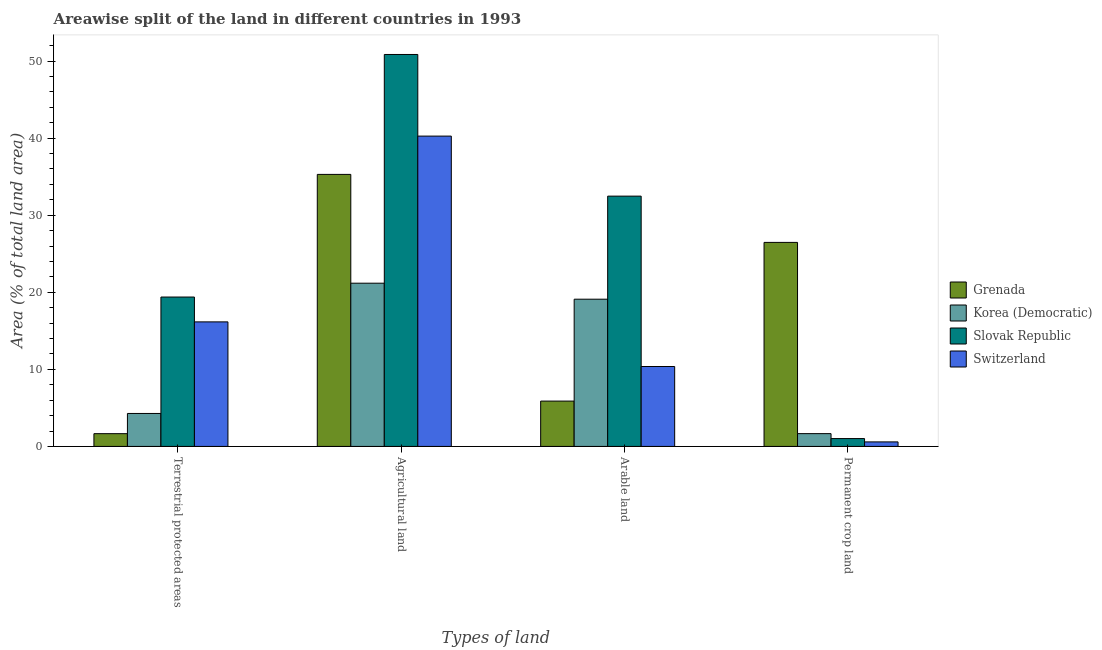How many different coloured bars are there?
Your answer should be very brief. 4. Are the number of bars per tick equal to the number of legend labels?
Provide a succinct answer. Yes. Are the number of bars on each tick of the X-axis equal?
Make the answer very short. Yes. What is the label of the 1st group of bars from the left?
Your response must be concise. Terrestrial protected areas. What is the percentage of area under arable land in Switzerland?
Provide a succinct answer. 10.37. Across all countries, what is the maximum percentage of land under terrestrial protection?
Your response must be concise. 19.38. Across all countries, what is the minimum percentage of area under arable land?
Give a very brief answer. 5.88. In which country was the percentage of area under agricultural land maximum?
Provide a succinct answer. Slovak Republic. In which country was the percentage of area under arable land minimum?
Provide a short and direct response. Grenada. What is the total percentage of area under permanent crop land in the graph?
Keep it short and to the point. 29.74. What is the difference between the percentage of land under terrestrial protection in Grenada and that in Slovak Republic?
Provide a succinct answer. -17.73. What is the difference between the percentage of area under permanent crop land in Slovak Republic and the percentage of area under agricultural land in Grenada?
Your answer should be compact. -34.28. What is the average percentage of area under permanent crop land per country?
Your response must be concise. 7.43. What is the difference between the percentage of area under arable land and percentage of area under permanent crop land in Grenada?
Make the answer very short. -20.59. In how many countries, is the percentage of area under arable land greater than 4 %?
Provide a short and direct response. 4. What is the ratio of the percentage of area under agricultural land in Korea (Democratic) to that in Switzerland?
Give a very brief answer. 0.53. What is the difference between the highest and the second highest percentage of land under terrestrial protection?
Keep it short and to the point. 3.22. What is the difference between the highest and the lowest percentage of land under terrestrial protection?
Offer a very short reply. 17.73. In how many countries, is the percentage of area under agricultural land greater than the average percentage of area under agricultural land taken over all countries?
Your response must be concise. 2. Is the sum of the percentage of area under arable land in Grenada and Switzerland greater than the maximum percentage of area under permanent crop land across all countries?
Offer a terse response. No. Is it the case that in every country, the sum of the percentage of area under arable land and percentage of area under permanent crop land is greater than the sum of percentage of area under agricultural land and percentage of land under terrestrial protection?
Ensure brevity in your answer.  No. What does the 2nd bar from the left in Permanent crop land represents?
Your response must be concise. Korea (Democratic). What does the 3rd bar from the right in Agricultural land represents?
Give a very brief answer. Korea (Democratic). How many bars are there?
Provide a short and direct response. 16. Are all the bars in the graph horizontal?
Provide a short and direct response. No. How many countries are there in the graph?
Make the answer very short. 4. What is the difference between two consecutive major ticks on the Y-axis?
Your answer should be very brief. 10. Does the graph contain any zero values?
Give a very brief answer. No. Does the graph contain grids?
Make the answer very short. No. Where does the legend appear in the graph?
Your answer should be compact. Center right. What is the title of the graph?
Provide a short and direct response. Areawise split of the land in different countries in 1993. Does "Benin" appear as one of the legend labels in the graph?
Keep it short and to the point. No. What is the label or title of the X-axis?
Give a very brief answer. Types of land. What is the label or title of the Y-axis?
Offer a very short reply. Area (% of total land area). What is the Area (% of total land area) in Grenada in Terrestrial protected areas?
Your response must be concise. 1.66. What is the Area (% of total land area) in Korea (Democratic) in Terrestrial protected areas?
Your response must be concise. 4.28. What is the Area (% of total land area) of Slovak Republic in Terrestrial protected areas?
Ensure brevity in your answer.  19.38. What is the Area (% of total land area) of Switzerland in Terrestrial protected areas?
Offer a terse response. 16.16. What is the Area (% of total land area) of Grenada in Agricultural land?
Your answer should be compact. 35.29. What is the Area (% of total land area) in Korea (Democratic) in Agricultural land?
Offer a very short reply. 21.18. What is the Area (% of total land area) in Slovak Republic in Agricultural land?
Your answer should be very brief. 50.85. What is the Area (% of total land area) in Switzerland in Agricultural land?
Your answer should be compact. 40.26. What is the Area (% of total land area) in Grenada in Arable land?
Offer a terse response. 5.88. What is the Area (% of total land area) of Korea (Democratic) in Arable land?
Provide a succinct answer. 19.1. What is the Area (% of total land area) of Slovak Republic in Arable land?
Give a very brief answer. 32.47. What is the Area (% of total land area) of Switzerland in Arable land?
Ensure brevity in your answer.  10.37. What is the Area (% of total land area) in Grenada in Permanent crop land?
Keep it short and to the point. 26.47. What is the Area (% of total land area) in Korea (Democratic) in Permanent crop land?
Offer a very short reply. 1.66. What is the Area (% of total land area) of Slovak Republic in Permanent crop land?
Provide a succinct answer. 1.02. What is the Area (% of total land area) of Switzerland in Permanent crop land?
Your answer should be compact. 0.59. Across all Types of land, what is the maximum Area (% of total land area) of Grenada?
Offer a terse response. 35.29. Across all Types of land, what is the maximum Area (% of total land area) in Korea (Democratic)?
Provide a succinct answer. 21.18. Across all Types of land, what is the maximum Area (% of total land area) of Slovak Republic?
Your answer should be very brief. 50.85. Across all Types of land, what is the maximum Area (% of total land area) of Switzerland?
Make the answer very short. 40.26. Across all Types of land, what is the minimum Area (% of total land area) in Grenada?
Provide a succinct answer. 1.66. Across all Types of land, what is the minimum Area (% of total land area) in Korea (Democratic)?
Your response must be concise. 1.66. Across all Types of land, what is the minimum Area (% of total land area) in Slovak Republic?
Offer a terse response. 1.02. Across all Types of land, what is the minimum Area (% of total land area) in Switzerland?
Give a very brief answer. 0.59. What is the total Area (% of total land area) of Grenada in the graph?
Ensure brevity in your answer.  69.3. What is the total Area (% of total land area) in Korea (Democratic) in the graph?
Give a very brief answer. 46.22. What is the total Area (% of total land area) in Slovak Republic in the graph?
Your answer should be compact. 103.73. What is the total Area (% of total land area) of Switzerland in the graph?
Offer a terse response. 67.38. What is the difference between the Area (% of total land area) of Grenada in Terrestrial protected areas and that in Agricultural land?
Your answer should be compact. -33.64. What is the difference between the Area (% of total land area) of Korea (Democratic) in Terrestrial protected areas and that in Agricultural land?
Offer a terse response. -16.9. What is the difference between the Area (% of total land area) of Slovak Republic in Terrestrial protected areas and that in Agricultural land?
Offer a terse response. -31.47. What is the difference between the Area (% of total land area) of Switzerland in Terrestrial protected areas and that in Agricultural land?
Your answer should be very brief. -24.1. What is the difference between the Area (% of total land area) of Grenada in Terrestrial protected areas and that in Arable land?
Provide a short and direct response. -4.23. What is the difference between the Area (% of total land area) in Korea (Democratic) in Terrestrial protected areas and that in Arable land?
Keep it short and to the point. -14.82. What is the difference between the Area (% of total land area) of Slovak Republic in Terrestrial protected areas and that in Arable land?
Provide a short and direct response. -13.09. What is the difference between the Area (% of total land area) in Switzerland in Terrestrial protected areas and that in Arable land?
Your answer should be very brief. 5.79. What is the difference between the Area (% of total land area) in Grenada in Terrestrial protected areas and that in Permanent crop land?
Offer a very short reply. -24.82. What is the difference between the Area (% of total land area) in Korea (Democratic) in Terrestrial protected areas and that in Permanent crop land?
Your answer should be very brief. 2.62. What is the difference between the Area (% of total land area) of Slovak Republic in Terrestrial protected areas and that in Permanent crop land?
Your answer should be very brief. 18.36. What is the difference between the Area (% of total land area) in Switzerland in Terrestrial protected areas and that in Permanent crop land?
Make the answer very short. 15.57. What is the difference between the Area (% of total land area) of Grenada in Agricultural land and that in Arable land?
Keep it short and to the point. 29.41. What is the difference between the Area (% of total land area) of Korea (Democratic) in Agricultural land and that in Arable land?
Your response must be concise. 2.08. What is the difference between the Area (% of total land area) in Slovak Republic in Agricultural land and that in Arable land?
Your answer should be very brief. 18.38. What is the difference between the Area (% of total land area) in Switzerland in Agricultural land and that in Arable land?
Keep it short and to the point. 29.89. What is the difference between the Area (% of total land area) of Grenada in Agricultural land and that in Permanent crop land?
Provide a short and direct response. 8.82. What is the difference between the Area (% of total land area) in Korea (Democratic) in Agricultural land and that in Permanent crop land?
Your answer should be compact. 19.52. What is the difference between the Area (% of total land area) in Slovak Republic in Agricultural land and that in Permanent crop land?
Your answer should be compact. 49.83. What is the difference between the Area (% of total land area) of Switzerland in Agricultural land and that in Permanent crop land?
Offer a very short reply. 39.67. What is the difference between the Area (% of total land area) of Grenada in Arable land and that in Permanent crop land?
Your response must be concise. -20.59. What is the difference between the Area (% of total land area) in Korea (Democratic) in Arable land and that in Permanent crop land?
Offer a very short reply. 17.44. What is the difference between the Area (% of total land area) in Slovak Republic in Arable land and that in Permanent crop land?
Offer a terse response. 31.46. What is the difference between the Area (% of total land area) in Switzerland in Arable land and that in Permanent crop land?
Your answer should be very brief. 9.78. What is the difference between the Area (% of total land area) in Grenada in Terrestrial protected areas and the Area (% of total land area) in Korea (Democratic) in Agricultural land?
Give a very brief answer. -19.52. What is the difference between the Area (% of total land area) of Grenada in Terrestrial protected areas and the Area (% of total land area) of Slovak Republic in Agricultural land?
Give a very brief answer. -49.2. What is the difference between the Area (% of total land area) of Grenada in Terrestrial protected areas and the Area (% of total land area) of Switzerland in Agricultural land?
Your answer should be compact. -38.61. What is the difference between the Area (% of total land area) in Korea (Democratic) in Terrestrial protected areas and the Area (% of total land area) in Slovak Republic in Agricultural land?
Your response must be concise. -46.58. What is the difference between the Area (% of total land area) in Korea (Democratic) in Terrestrial protected areas and the Area (% of total land area) in Switzerland in Agricultural land?
Keep it short and to the point. -35.98. What is the difference between the Area (% of total land area) in Slovak Republic in Terrestrial protected areas and the Area (% of total land area) in Switzerland in Agricultural land?
Ensure brevity in your answer.  -20.88. What is the difference between the Area (% of total land area) of Grenada in Terrestrial protected areas and the Area (% of total land area) of Korea (Democratic) in Arable land?
Give a very brief answer. -17.45. What is the difference between the Area (% of total land area) of Grenada in Terrestrial protected areas and the Area (% of total land area) of Slovak Republic in Arable land?
Provide a short and direct response. -30.82. What is the difference between the Area (% of total land area) of Grenada in Terrestrial protected areas and the Area (% of total land area) of Switzerland in Arable land?
Your answer should be very brief. -8.71. What is the difference between the Area (% of total land area) of Korea (Democratic) in Terrestrial protected areas and the Area (% of total land area) of Slovak Republic in Arable land?
Make the answer very short. -28.2. What is the difference between the Area (% of total land area) in Korea (Democratic) in Terrestrial protected areas and the Area (% of total land area) in Switzerland in Arable land?
Make the answer very short. -6.09. What is the difference between the Area (% of total land area) of Slovak Republic in Terrestrial protected areas and the Area (% of total land area) of Switzerland in Arable land?
Give a very brief answer. 9.01. What is the difference between the Area (% of total land area) of Grenada in Terrestrial protected areas and the Area (% of total land area) of Korea (Democratic) in Permanent crop land?
Ensure brevity in your answer.  -0.01. What is the difference between the Area (% of total land area) of Grenada in Terrestrial protected areas and the Area (% of total land area) of Slovak Republic in Permanent crop land?
Make the answer very short. 0.64. What is the difference between the Area (% of total land area) of Grenada in Terrestrial protected areas and the Area (% of total land area) of Switzerland in Permanent crop land?
Offer a very short reply. 1.07. What is the difference between the Area (% of total land area) in Korea (Democratic) in Terrestrial protected areas and the Area (% of total land area) in Slovak Republic in Permanent crop land?
Your answer should be compact. 3.26. What is the difference between the Area (% of total land area) in Korea (Democratic) in Terrestrial protected areas and the Area (% of total land area) in Switzerland in Permanent crop land?
Your answer should be compact. 3.69. What is the difference between the Area (% of total land area) of Slovak Republic in Terrestrial protected areas and the Area (% of total land area) of Switzerland in Permanent crop land?
Your response must be concise. 18.8. What is the difference between the Area (% of total land area) in Grenada in Agricultural land and the Area (% of total land area) in Korea (Democratic) in Arable land?
Your response must be concise. 16.19. What is the difference between the Area (% of total land area) of Grenada in Agricultural land and the Area (% of total land area) of Slovak Republic in Arable land?
Give a very brief answer. 2.82. What is the difference between the Area (% of total land area) in Grenada in Agricultural land and the Area (% of total land area) in Switzerland in Arable land?
Provide a succinct answer. 24.92. What is the difference between the Area (% of total land area) in Korea (Democratic) in Agricultural land and the Area (% of total land area) in Slovak Republic in Arable land?
Make the answer very short. -11.3. What is the difference between the Area (% of total land area) in Korea (Democratic) in Agricultural land and the Area (% of total land area) in Switzerland in Arable land?
Offer a very short reply. 10.81. What is the difference between the Area (% of total land area) of Slovak Republic in Agricultural land and the Area (% of total land area) of Switzerland in Arable land?
Offer a terse response. 40.48. What is the difference between the Area (% of total land area) of Grenada in Agricultural land and the Area (% of total land area) of Korea (Democratic) in Permanent crop land?
Offer a very short reply. 33.63. What is the difference between the Area (% of total land area) in Grenada in Agricultural land and the Area (% of total land area) in Slovak Republic in Permanent crop land?
Keep it short and to the point. 34.28. What is the difference between the Area (% of total land area) in Grenada in Agricultural land and the Area (% of total land area) in Switzerland in Permanent crop land?
Your answer should be compact. 34.71. What is the difference between the Area (% of total land area) in Korea (Democratic) in Agricultural land and the Area (% of total land area) in Slovak Republic in Permanent crop land?
Ensure brevity in your answer.  20.16. What is the difference between the Area (% of total land area) in Korea (Democratic) in Agricultural land and the Area (% of total land area) in Switzerland in Permanent crop land?
Provide a succinct answer. 20.59. What is the difference between the Area (% of total land area) in Slovak Republic in Agricultural land and the Area (% of total land area) in Switzerland in Permanent crop land?
Provide a short and direct response. 50.27. What is the difference between the Area (% of total land area) in Grenada in Arable land and the Area (% of total land area) in Korea (Democratic) in Permanent crop land?
Offer a terse response. 4.22. What is the difference between the Area (% of total land area) in Grenada in Arable land and the Area (% of total land area) in Slovak Republic in Permanent crop land?
Make the answer very short. 4.86. What is the difference between the Area (% of total land area) in Grenada in Arable land and the Area (% of total land area) in Switzerland in Permanent crop land?
Offer a terse response. 5.3. What is the difference between the Area (% of total land area) in Korea (Democratic) in Arable land and the Area (% of total land area) in Slovak Republic in Permanent crop land?
Keep it short and to the point. 18.08. What is the difference between the Area (% of total land area) in Korea (Democratic) in Arable land and the Area (% of total land area) in Switzerland in Permanent crop land?
Make the answer very short. 18.51. What is the difference between the Area (% of total land area) of Slovak Republic in Arable land and the Area (% of total land area) of Switzerland in Permanent crop land?
Offer a very short reply. 31.89. What is the average Area (% of total land area) of Grenada per Types of land?
Your answer should be very brief. 17.33. What is the average Area (% of total land area) in Korea (Democratic) per Types of land?
Offer a very short reply. 11.55. What is the average Area (% of total land area) in Slovak Republic per Types of land?
Your response must be concise. 25.93. What is the average Area (% of total land area) in Switzerland per Types of land?
Keep it short and to the point. 16.84. What is the difference between the Area (% of total land area) in Grenada and Area (% of total land area) in Korea (Democratic) in Terrestrial protected areas?
Offer a terse response. -2.62. What is the difference between the Area (% of total land area) of Grenada and Area (% of total land area) of Slovak Republic in Terrestrial protected areas?
Provide a succinct answer. -17.73. What is the difference between the Area (% of total land area) of Grenada and Area (% of total land area) of Switzerland in Terrestrial protected areas?
Your answer should be compact. -14.5. What is the difference between the Area (% of total land area) of Korea (Democratic) and Area (% of total land area) of Slovak Republic in Terrestrial protected areas?
Give a very brief answer. -15.11. What is the difference between the Area (% of total land area) of Korea (Democratic) and Area (% of total land area) of Switzerland in Terrestrial protected areas?
Provide a short and direct response. -11.88. What is the difference between the Area (% of total land area) in Slovak Republic and Area (% of total land area) in Switzerland in Terrestrial protected areas?
Your answer should be very brief. 3.22. What is the difference between the Area (% of total land area) in Grenada and Area (% of total land area) in Korea (Democratic) in Agricultural land?
Offer a terse response. 14.12. What is the difference between the Area (% of total land area) of Grenada and Area (% of total land area) of Slovak Republic in Agricultural land?
Provide a succinct answer. -15.56. What is the difference between the Area (% of total land area) in Grenada and Area (% of total land area) in Switzerland in Agricultural land?
Give a very brief answer. -4.97. What is the difference between the Area (% of total land area) of Korea (Democratic) and Area (% of total land area) of Slovak Republic in Agricultural land?
Offer a terse response. -29.67. What is the difference between the Area (% of total land area) of Korea (Democratic) and Area (% of total land area) of Switzerland in Agricultural land?
Offer a terse response. -19.08. What is the difference between the Area (% of total land area) of Slovak Republic and Area (% of total land area) of Switzerland in Agricultural land?
Provide a short and direct response. 10.59. What is the difference between the Area (% of total land area) in Grenada and Area (% of total land area) in Korea (Democratic) in Arable land?
Keep it short and to the point. -13.22. What is the difference between the Area (% of total land area) in Grenada and Area (% of total land area) in Slovak Republic in Arable land?
Provide a succinct answer. -26.59. What is the difference between the Area (% of total land area) in Grenada and Area (% of total land area) in Switzerland in Arable land?
Ensure brevity in your answer.  -4.49. What is the difference between the Area (% of total land area) in Korea (Democratic) and Area (% of total land area) in Slovak Republic in Arable land?
Provide a succinct answer. -13.37. What is the difference between the Area (% of total land area) in Korea (Democratic) and Area (% of total land area) in Switzerland in Arable land?
Keep it short and to the point. 8.73. What is the difference between the Area (% of total land area) of Slovak Republic and Area (% of total land area) of Switzerland in Arable land?
Your answer should be very brief. 22.1. What is the difference between the Area (% of total land area) in Grenada and Area (% of total land area) in Korea (Democratic) in Permanent crop land?
Your response must be concise. 24.81. What is the difference between the Area (% of total land area) of Grenada and Area (% of total land area) of Slovak Republic in Permanent crop land?
Your answer should be compact. 25.45. What is the difference between the Area (% of total land area) of Grenada and Area (% of total land area) of Switzerland in Permanent crop land?
Ensure brevity in your answer.  25.88. What is the difference between the Area (% of total land area) in Korea (Democratic) and Area (% of total land area) in Slovak Republic in Permanent crop land?
Your answer should be very brief. 0.64. What is the difference between the Area (% of total land area) of Korea (Democratic) and Area (% of total land area) of Switzerland in Permanent crop land?
Your answer should be compact. 1.07. What is the difference between the Area (% of total land area) of Slovak Republic and Area (% of total land area) of Switzerland in Permanent crop land?
Offer a terse response. 0.43. What is the ratio of the Area (% of total land area) in Grenada in Terrestrial protected areas to that in Agricultural land?
Your answer should be compact. 0.05. What is the ratio of the Area (% of total land area) of Korea (Democratic) in Terrestrial protected areas to that in Agricultural land?
Provide a succinct answer. 0.2. What is the ratio of the Area (% of total land area) of Slovak Republic in Terrestrial protected areas to that in Agricultural land?
Give a very brief answer. 0.38. What is the ratio of the Area (% of total land area) of Switzerland in Terrestrial protected areas to that in Agricultural land?
Provide a succinct answer. 0.4. What is the ratio of the Area (% of total land area) of Grenada in Terrestrial protected areas to that in Arable land?
Give a very brief answer. 0.28. What is the ratio of the Area (% of total land area) of Korea (Democratic) in Terrestrial protected areas to that in Arable land?
Give a very brief answer. 0.22. What is the ratio of the Area (% of total land area) of Slovak Republic in Terrestrial protected areas to that in Arable land?
Keep it short and to the point. 0.6. What is the ratio of the Area (% of total land area) of Switzerland in Terrestrial protected areas to that in Arable land?
Make the answer very short. 1.56. What is the ratio of the Area (% of total land area) of Grenada in Terrestrial protected areas to that in Permanent crop land?
Keep it short and to the point. 0.06. What is the ratio of the Area (% of total land area) in Korea (Democratic) in Terrestrial protected areas to that in Permanent crop land?
Your answer should be very brief. 2.57. What is the ratio of the Area (% of total land area) in Slovak Republic in Terrestrial protected areas to that in Permanent crop land?
Provide a short and direct response. 19.03. What is the ratio of the Area (% of total land area) in Switzerland in Terrestrial protected areas to that in Permanent crop land?
Your answer should be compact. 27.53. What is the ratio of the Area (% of total land area) in Korea (Democratic) in Agricultural land to that in Arable land?
Keep it short and to the point. 1.11. What is the ratio of the Area (% of total land area) in Slovak Republic in Agricultural land to that in Arable land?
Offer a very short reply. 1.57. What is the ratio of the Area (% of total land area) of Switzerland in Agricultural land to that in Arable land?
Offer a terse response. 3.88. What is the ratio of the Area (% of total land area) of Grenada in Agricultural land to that in Permanent crop land?
Your answer should be very brief. 1.33. What is the ratio of the Area (% of total land area) in Korea (Democratic) in Agricultural land to that in Permanent crop land?
Your answer should be compact. 12.75. What is the ratio of the Area (% of total land area) of Slovak Republic in Agricultural land to that in Permanent crop land?
Ensure brevity in your answer.  49.92. What is the ratio of the Area (% of total land area) in Switzerland in Agricultural land to that in Permanent crop land?
Offer a very short reply. 68.6. What is the ratio of the Area (% of total land area) of Grenada in Arable land to that in Permanent crop land?
Offer a terse response. 0.22. What is the ratio of the Area (% of total land area) of Slovak Republic in Arable land to that in Permanent crop land?
Your response must be concise. 31.88. What is the ratio of the Area (% of total land area) in Switzerland in Arable land to that in Permanent crop land?
Your answer should be compact. 17.67. What is the difference between the highest and the second highest Area (% of total land area) of Grenada?
Provide a succinct answer. 8.82. What is the difference between the highest and the second highest Area (% of total land area) in Korea (Democratic)?
Your answer should be compact. 2.08. What is the difference between the highest and the second highest Area (% of total land area) of Slovak Republic?
Offer a terse response. 18.38. What is the difference between the highest and the second highest Area (% of total land area) in Switzerland?
Give a very brief answer. 24.1. What is the difference between the highest and the lowest Area (% of total land area) of Grenada?
Your answer should be compact. 33.64. What is the difference between the highest and the lowest Area (% of total land area) of Korea (Democratic)?
Offer a terse response. 19.52. What is the difference between the highest and the lowest Area (% of total land area) in Slovak Republic?
Provide a short and direct response. 49.83. What is the difference between the highest and the lowest Area (% of total land area) of Switzerland?
Keep it short and to the point. 39.67. 